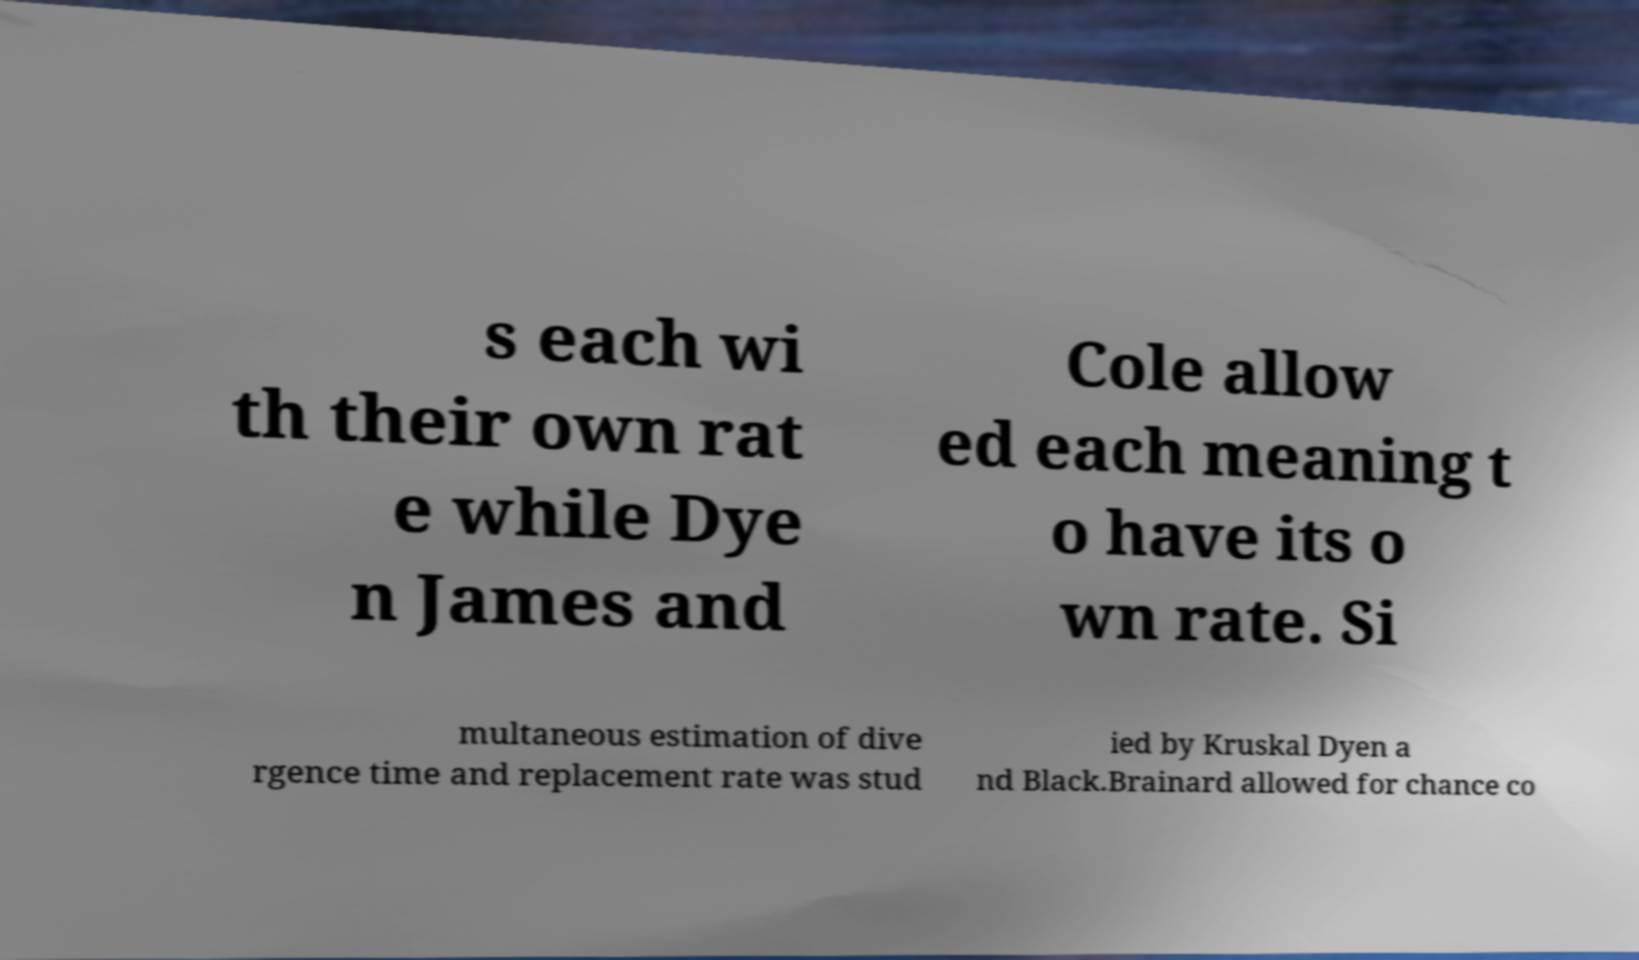Please identify and transcribe the text found in this image. s each wi th their own rat e while Dye n James and Cole allow ed each meaning t o have its o wn rate. Si multaneous estimation of dive rgence time and replacement rate was stud ied by Kruskal Dyen a nd Black.Brainard allowed for chance co 